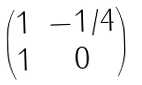Convert formula to latex. <formula><loc_0><loc_0><loc_500><loc_500>\begin{pmatrix} 1 & - 1 / 4 \\ 1 & 0 \end{pmatrix}</formula> 